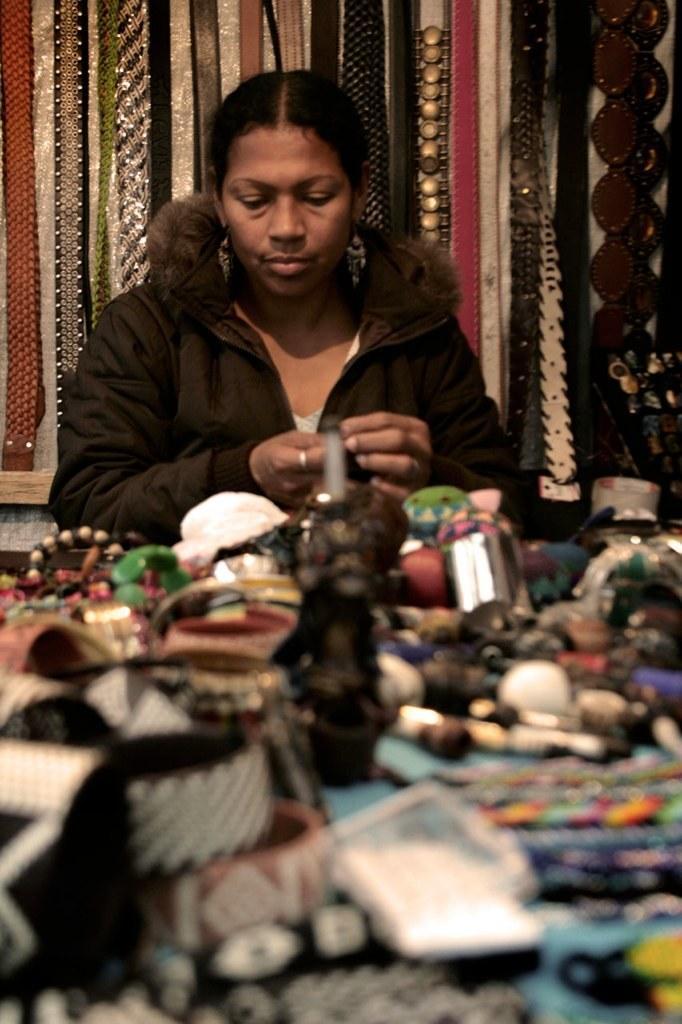In one or two sentences, can you explain what this image depicts? In this image there is a lady sitting on the chair, there are few objects on the table and few objects hanging from the wall. 